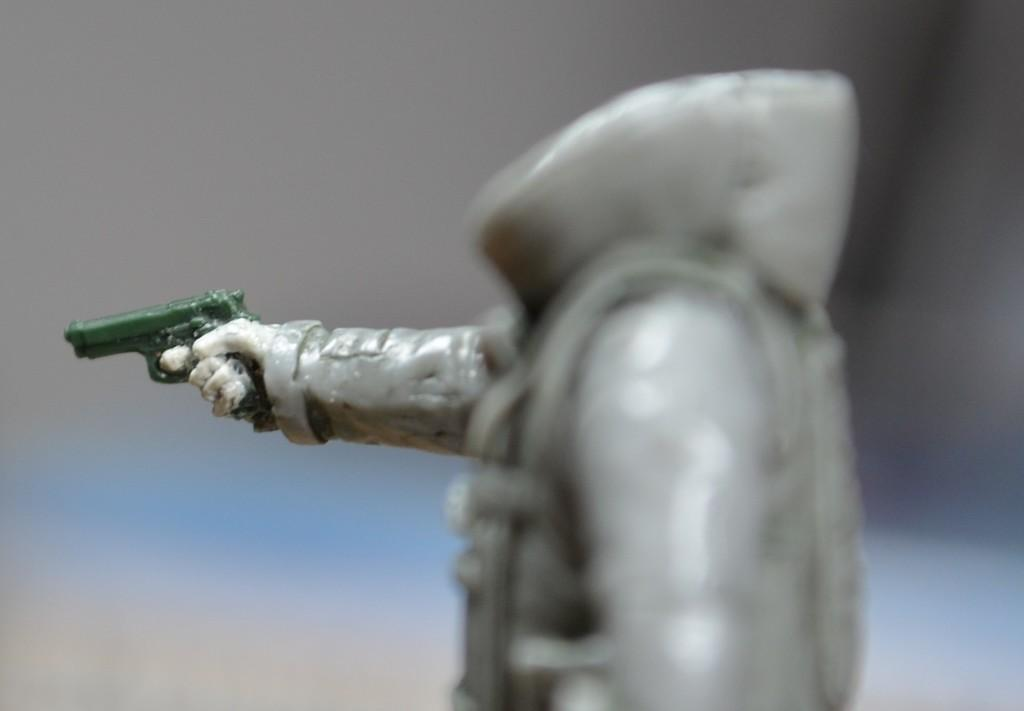What object can be seen in the image? There is a toy in the image. What is the toy holding? The toy is holding a green gun. Can you describe the background of the image? The background of the image is blurred. What type of protest is happening in the background of the image? There is no protest visible in the image; the background is blurred. Can you see any goats or rats in the image? There are no goats or rats present in the image; it features a toy holding a green gun. 